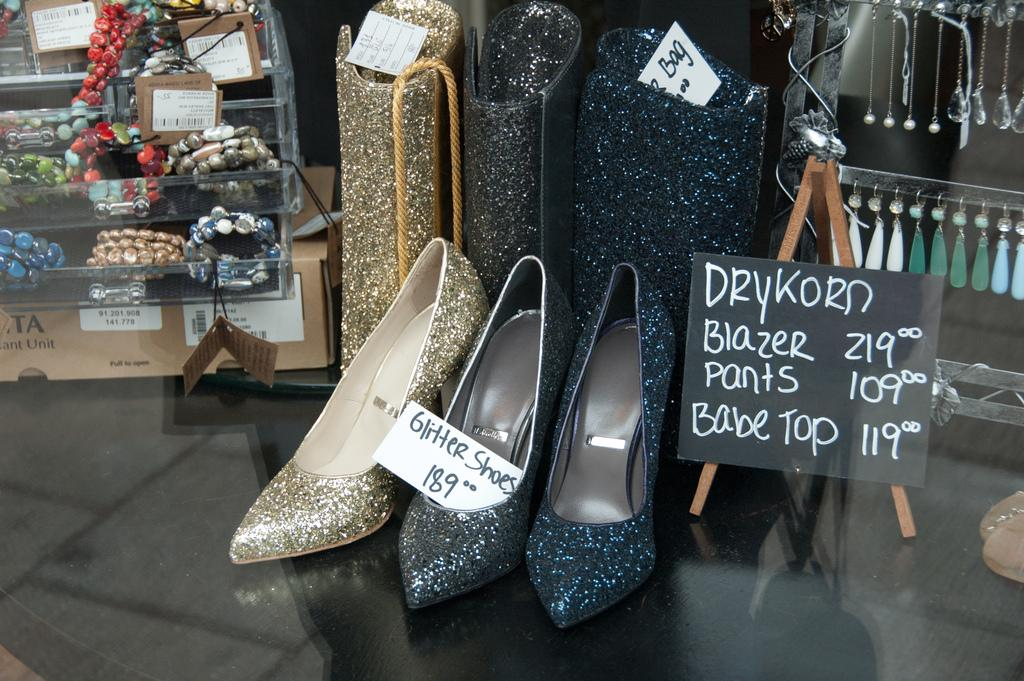What is located in the middle of the image? There are shoes in the middle of the image. What information can be found in the image? There is a price card in the image. What is on the right side of the image? There is a black color board on the right side of the image. How many potatoes are visible on the black color board in the image? There are no potatoes present on the black color board in the image. What type of shade is covering the shoes in the image? There is no shade covering the shoes in the image; they are directly exposed to the environment. 